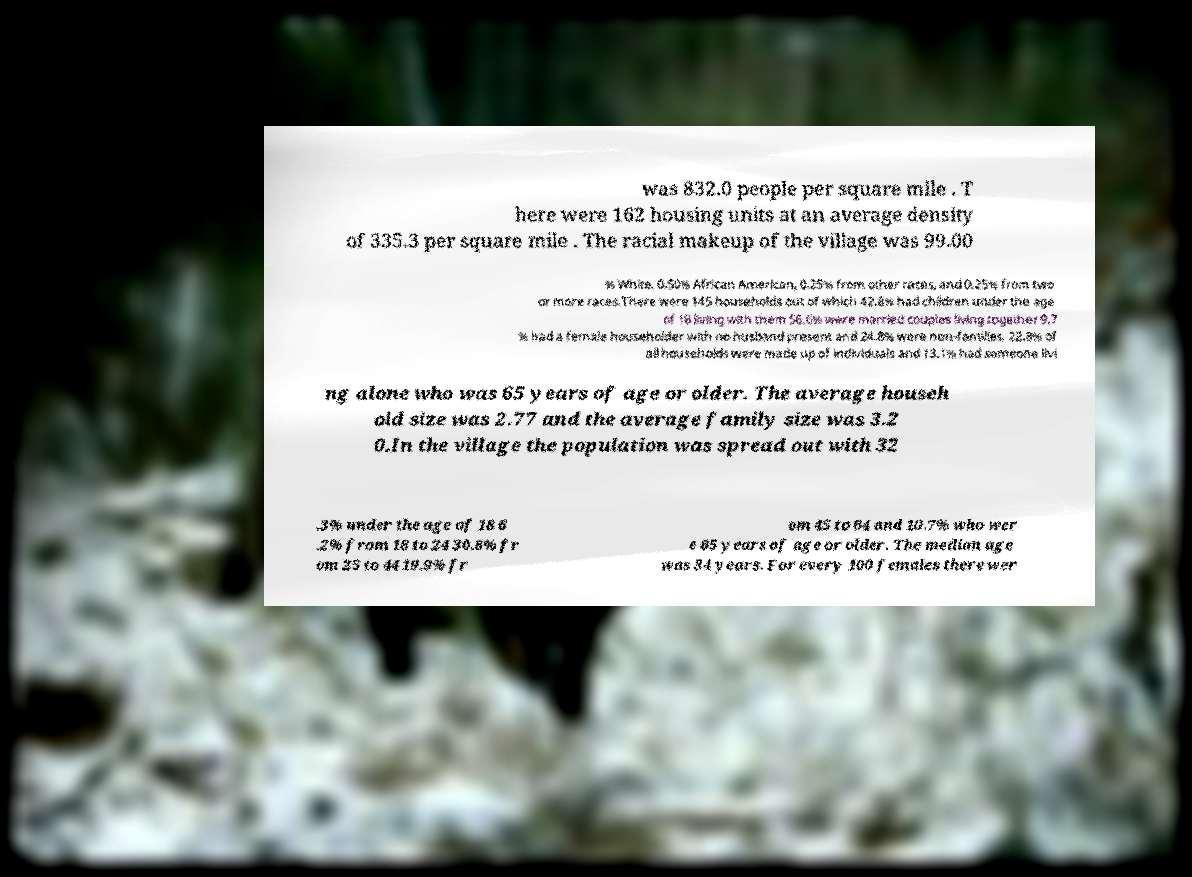Please read and relay the text visible in this image. What does it say? was 832.0 people per square mile . T here were 162 housing units at an average density of 335.3 per square mile . The racial makeup of the village was 99.00 % White, 0.50% African American, 0.25% from other races, and 0.25% from two or more races.There were 145 households out of which 42.8% had children under the age of 18 living with them 56.6% were married couples living together 9.7 % had a female householder with no husband present and 24.8% were non-families. 22.8% of all households were made up of individuals and 13.1% had someone livi ng alone who was 65 years of age or older. The average househ old size was 2.77 and the average family size was 3.2 0.In the village the population was spread out with 32 .3% under the age of 18 6 .2% from 18 to 24 30.8% fr om 25 to 44 19.9% fr om 45 to 64 and 10.7% who wer e 65 years of age or older. The median age was 34 years. For every 100 females there wer 